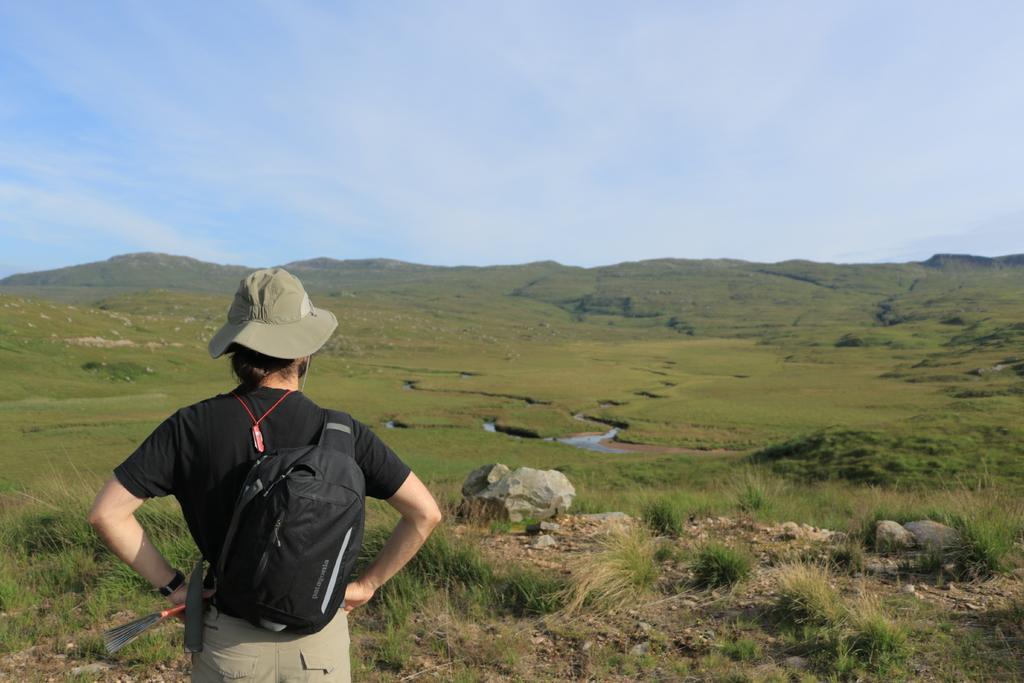Please provide a concise description of this image. In this image I can see a person standing wearing black shirt, cream pant and black color bag. Background I can see grass in green color and sky in blue and white color. 